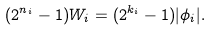<formula> <loc_0><loc_0><loc_500><loc_500>( 2 ^ { n _ { i } } - 1 ) W _ { i } = ( 2 ^ { k _ { i } } - 1 ) | \phi _ { i } | .</formula> 